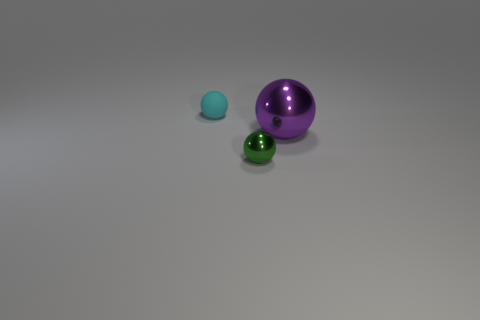Subtract all metal balls. How many balls are left? 1 Add 1 matte spheres. How many objects exist? 4 Subtract all green balls. How many balls are left? 2 Subtract 2 spheres. How many spheres are left? 1 Subtract 0 blue cylinders. How many objects are left? 3 Subtract all green spheres. Subtract all blue cylinders. How many spheres are left? 2 Subtract all blue blocks. How many blue balls are left? 0 Subtract all green objects. Subtract all green metal things. How many objects are left? 1 Add 2 matte balls. How many matte balls are left? 3 Add 1 large balls. How many large balls exist? 2 